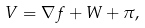<formula> <loc_0><loc_0><loc_500><loc_500>V = \nabla f + W + \pi ,</formula> 